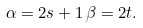Convert formula to latex. <formula><loc_0><loc_0><loc_500><loc_500>\alpha = 2 s + 1 \, \beta = 2 t .</formula> 